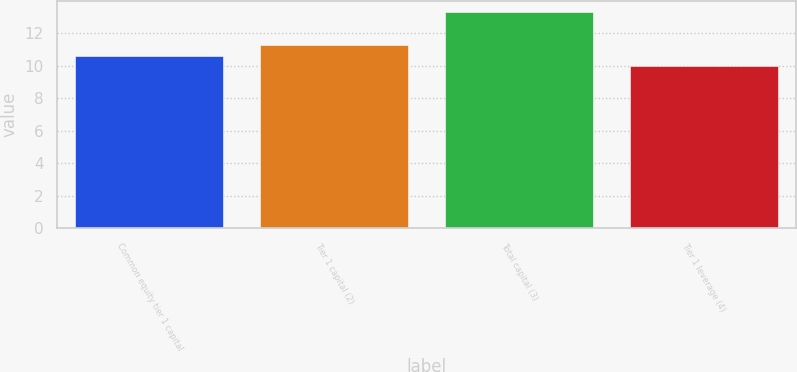Convert chart. <chart><loc_0><loc_0><loc_500><loc_500><bar_chart><fcel>Common equity tier 1 capital<fcel>Tier 1 capital (2)<fcel>Total capital (3)<fcel>Tier 1 leverage (4)<nl><fcel>10.6<fcel>11.3<fcel>13.3<fcel>10<nl></chart> 